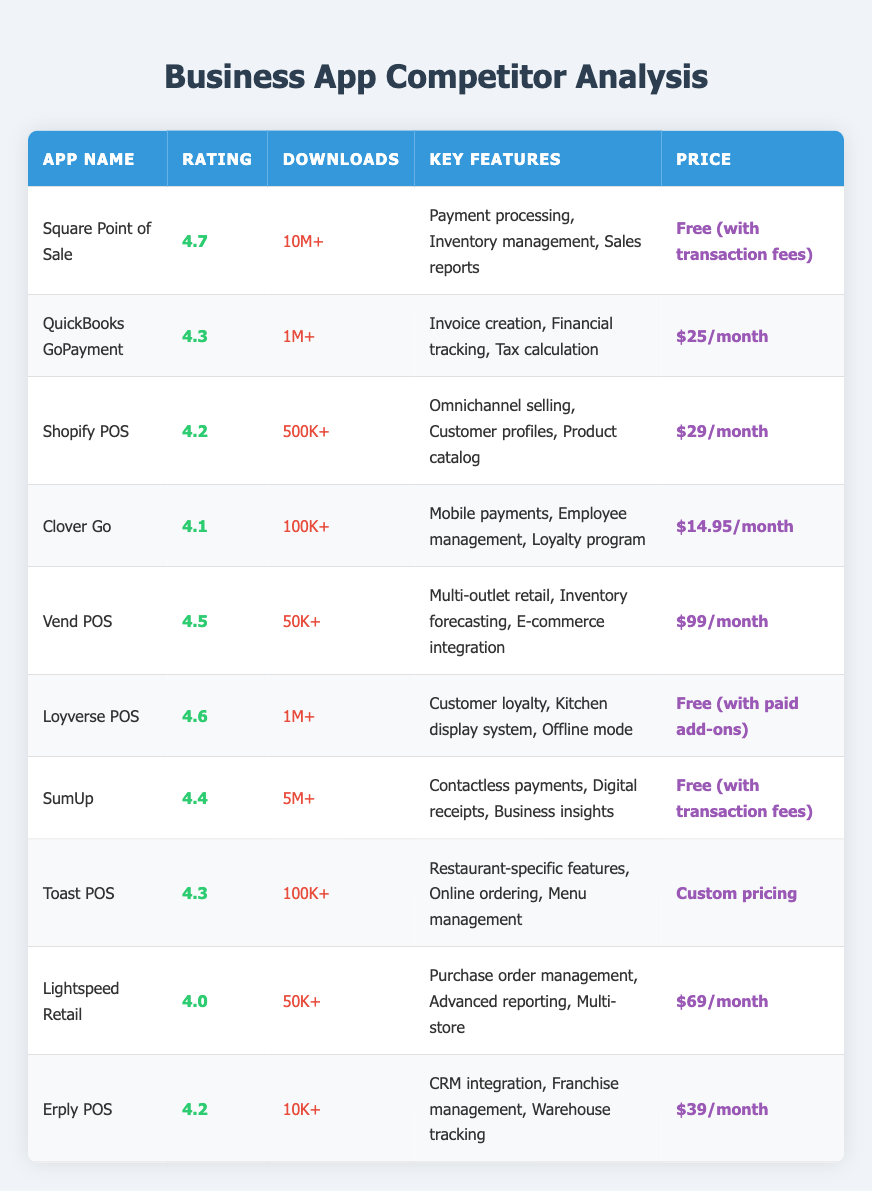What is the highest-rated app in the table? By examining the 'Rating' column, we can identify that the app with the highest rating is 'Square Point of Sale,' which has a rating of 4.7.
Answer: Square Point of Sale Which app has the most downloads? Looking at the 'Downloads' column, 'Square Point of Sale' is listed with '10M+', the highest figure present.
Answer: Square Point of Sale How many apps are free to use? From the 'Price' column, we can count 'Square Point of Sale,' 'Loyverse POS,' and 'SumUp,' totalling to three apps that are free to use.
Answer: 3 What is the average rating of the apps listed? To calculate the average rating, we sum the values (4.7 + 4.3 + 4.2 + 4.1 + 4.5 + 4.6 + 4.4 + 4.3 + 4.0 + 4.2), which equals 44.3. Dividing this by the total count of apps (10) gives us an average rating of 4.43.
Answer: 4.43 Is 'Toast POS' the only app listed with custom pricing? By examining the 'Price' column, we find that only 'Toast POS' has the pricing listed as 'Custom pricing,' indicating that it is not shared by any other app. Thus, the statement is true.
Answer: Yes Which app has the lowest number of downloads? Reviewing the 'Downloads' column, 'Erply POS' has the lowest at '10K+', which is less than all others.
Answer: Erply POS How many apps cost more than $30 per month? In the 'Price' column, Apps listed with prices exceeding $30 are 'Vend POS' ($99/month) and 'Lightspeed Retail' ($69/month), resulting in a total of two apps.
Answer: 2 What is the pricing difference between the highest and lowest priced apps? 'Vend POS' is priced at $99/month and 'Clover Go' at $14.95/month. To find the difference, we subtract $14.95 from $99, which equals $84.05.
Answer: $84.05 Which app offers restaurant-specific features? Looking at the 'Key Features' column, 'Toast POS' is noted to offer restaurant-specific features, including online ordering and menu management.
Answer: Toast POS 